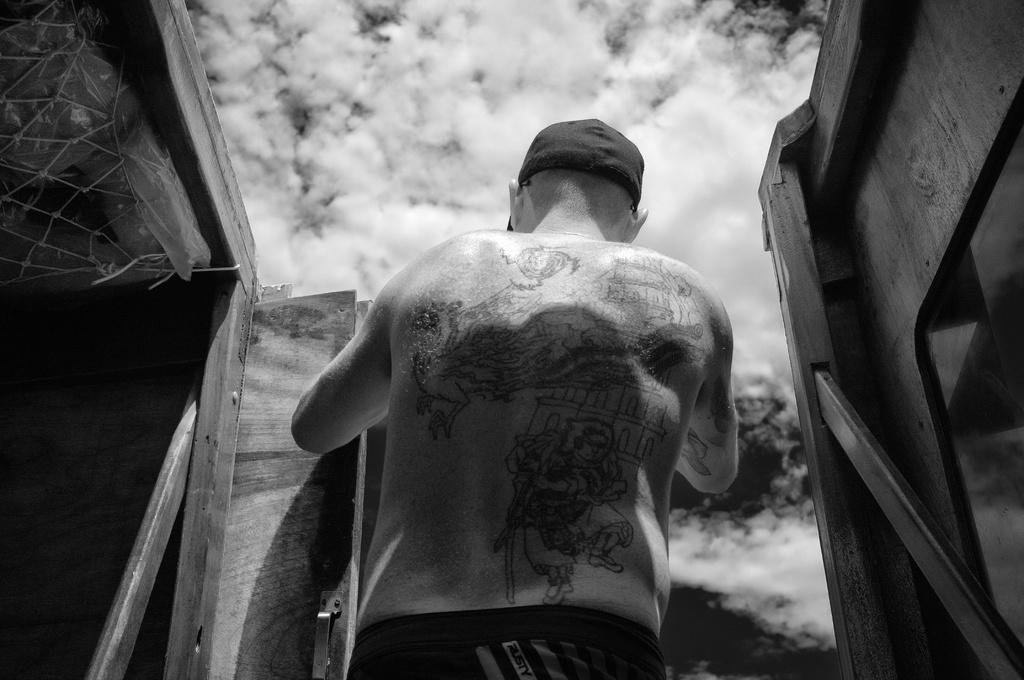Could you give a brief overview of what you see in this image? This is a black and white image. We can see a person. We can see some objects on the left and some objects on the right. We can also see the sky with clouds. 